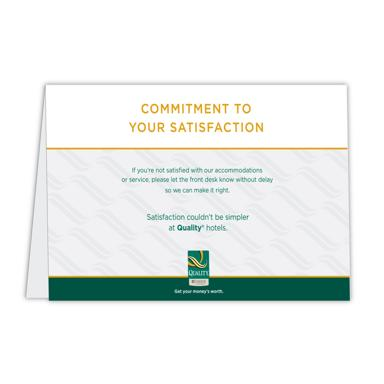Can you describe the design elements used on this business card? The business card features a clean and professional design with a dominant white background and subtle gray patterns offering a textured look. It has golden and dark green trimmings that align with the corporate colors of Quality Hotels, suggesting a sense of luxury and reliability. The typeface is modern and accessible, enhancing readability. 